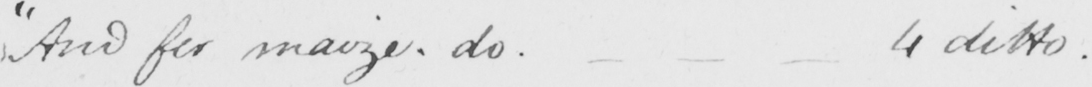Please transcribe the handwritten text in this image. " And for maize , do .  _   _   _  4 ditto . 